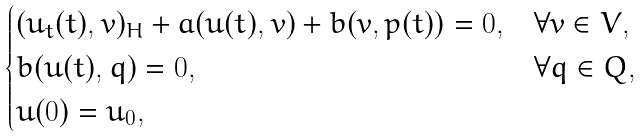Convert formula to latex. <formula><loc_0><loc_0><loc_500><loc_500>\begin{cases} ( u _ { t } ( t ) , v ) _ { H } + a ( u ( t ) , v ) + b ( v , p ( t ) ) = 0 , & \forall v \in V , \\ b ( u ( t ) , q ) = 0 , & \forall q \in Q , \\ u ( 0 ) = u _ { 0 } , \end{cases}</formula> 